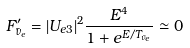<formula> <loc_0><loc_0><loc_500><loc_500>F ^ { \prime } _ { \bar { \nu } _ { e } } = | U _ { e 3 } | ^ { 2 } \frac { E ^ { 4 } } { 1 + e ^ { E / T _ { \bar { \nu } _ { e } } } } \simeq 0</formula> 